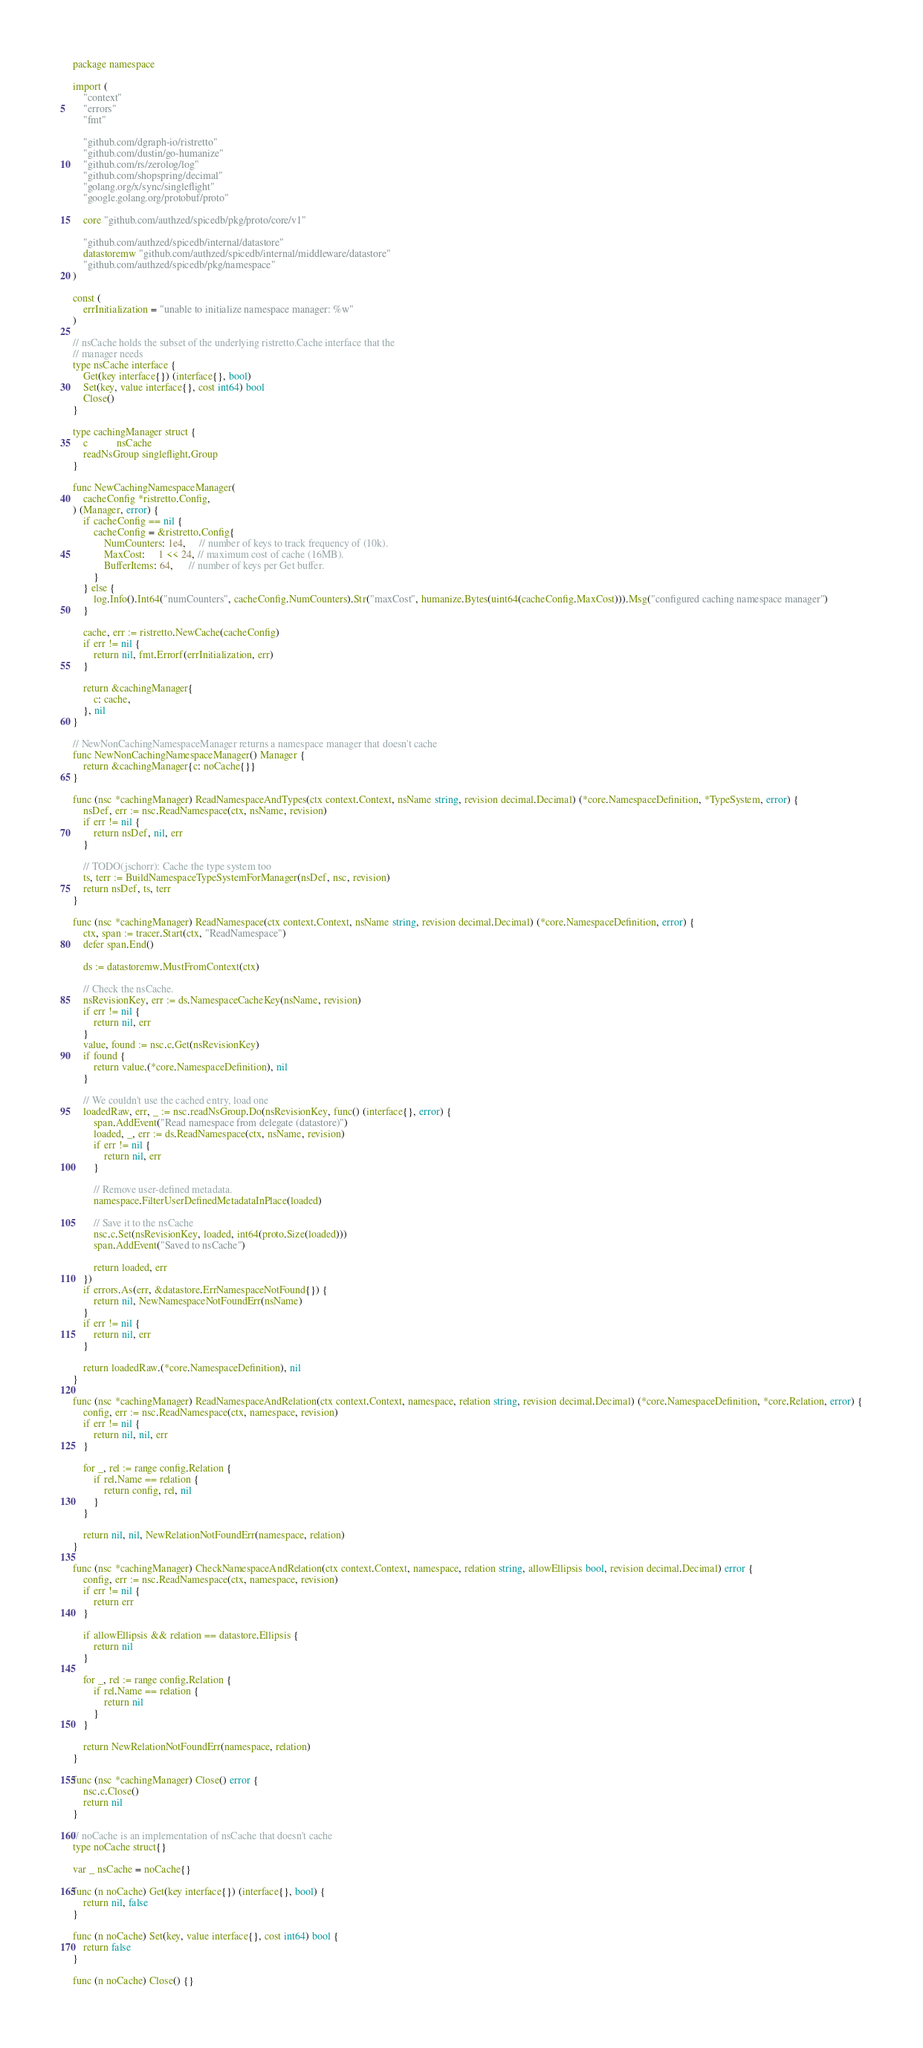Convert code to text. <code><loc_0><loc_0><loc_500><loc_500><_Go_>package namespace

import (
	"context"
	"errors"
	"fmt"

	"github.com/dgraph-io/ristretto"
	"github.com/dustin/go-humanize"
	"github.com/rs/zerolog/log"
	"github.com/shopspring/decimal"
	"golang.org/x/sync/singleflight"
	"google.golang.org/protobuf/proto"

	core "github.com/authzed/spicedb/pkg/proto/core/v1"

	"github.com/authzed/spicedb/internal/datastore"
	datastoremw "github.com/authzed/spicedb/internal/middleware/datastore"
	"github.com/authzed/spicedb/pkg/namespace"
)

const (
	errInitialization = "unable to initialize namespace manager: %w"
)

// nsCache holds the subset of the underlying ristretto.Cache interface that the
// manager needs
type nsCache interface {
	Get(key interface{}) (interface{}, bool)
	Set(key, value interface{}, cost int64) bool
	Close()
}

type cachingManager struct {
	c           nsCache
	readNsGroup singleflight.Group
}

func NewCachingNamespaceManager(
	cacheConfig *ristretto.Config,
) (Manager, error) {
	if cacheConfig == nil {
		cacheConfig = &ristretto.Config{
			NumCounters: 1e4,     // number of keys to track frequency of (10k).
			MaxCost:     1 << 24, // maximum cost of cache (16MB).
			BufferItems: 64,      // number of keys per Get buffer.
		}
	} else {
		log.Info().Int64("numCounters", cacheConfig.NumCounters).Str("maxCost", humanize.Bytes(uint64(cacheConfig.MaxCost))).Msg("configured caching namespace manager")
	}

	cache, err := ristretto.NewCache(cacheConfig)
	if err != nil {
		return nil, fmt.Errorf(errInitialization, err)
	}

	return &cachingManager{
		c: cache,
	}, nil
}

// NewNonCachingNamespaceManager returns a namespace manager that doesn't cache
func NewNonCachingNamespaceManager() Manager {
	return &cachingManager{c: noCache{}}
}

func (nsc *cachingManager) ReadNamespaceAndTypes(ctx context.Context, nsName string, revision decimal.Decimal) (*core.NamespaceDefinition, *TypeSystem, error) {
	nsDef, err := nsc.ReadNamespace(ctx, nsName, revision)
	if err != nil {
		return nsDef, nil, err
	}

	// TODO(jschorr): Cache the type system too
	ts, terr := BuildNamespaceTypeSystemForManager(nsDef, nsc, revision)
	return nsDef, ts, terr
}

func (nsc *cachingManager) ReadNamespace(ctx context.Context, nsName string, revision decimal.Decimal) (*core.NamespaceDefinition, error) {
	ctx, span := tracer.Start(ctx, "ReadNamespace")
	defer span.End()

	ds := datastoremw.MustFromContext(ctx)

	// Check the nsCache.
	nsRevisionKey, err := ds.NamespaceCacheKey(nsName, revision)
	if err != nil {
		return nil, err
	}
	value, found := nsc.c.Get(nsRevisionKey)
	if found {
		return value.(*core.NamespaceDefinition), nil
	}

	// We couldn't use the cached entry, load one
	loadedRaw, err, _ := nsc.readNsGroup.Do(nsRevisionKey, func() (interface{}, error) {
		span.AddEvent("Read namespace from delegate (datastore)")
		loaded, _, err := ds.ReadNamespace(ctx, nsName, revision)
		if err != nil {
			return nil, err
		}

		// Remove user-defined metadata.
		namespace.FilterUserDefinedMetadataInPlace(loaded)

		// Save it to the nsCache
		nsc.c.Set(nsRevisionKey, loaded, int64(proto.Size(loaded)))
		span.AddEvent("Saved to nsCache")

		return loaded, err
	})
	if errors.As(err, &datastore.ErrNamespaceNotFound{}) {
		return nil, NewNamespaceNotFoundErr(nsName)
	}
	if err != nil {
		return nil, err
	}

	return loadedRaw.(*core.NamespaceDefinition), nil
}

func (nsc *cachingManager) ReadNamespaceAndRelation(ctx context.Context, namespace, relation string, revision decimal.Decimal) (*core.NamespaceDefinition, *core.Relation, error) {
	config, err := nsc.ReadNamespace(ctx, namespace, revision)
	if err != nil {
		return nil, nil, err
	}

	for _, rel := range config.Relation {
		if rel.Name == relation {
			return config, rel, nil
		}
	}

	return nil, nil, NewRelationNotFoundErr(namespace, relation)
}

func (nsc *cachingManager) CheckNamespaceAndRelation(ctx context.Context, namespace, relation string, allowEllipsis bool, revision decimal.Decimal) error {
	config, err := nsc.ReadNamespace(ctx, namespace, revision)
	if err != nil {
		return err
	}

	if allowEllipsis && relation == datastore.Ellipsis {
		return nil
	}

	for _, rel := range config.Relation {
		if rel.Name == relation {
			return nil
		}
	}

	return NewRelationNotFoundErr(namespace, relation)
}

func (nsc *cachingManager) Close() error {
	nsc.c.Close()
	return nil
}

// noCache is an implementation of nsCache that doesn't cache
type noCache struct{}

var _ nsCache = noCache{}

func (n noCache) Get(key interface{}) (interface{}, bool) {
	return nil, false
}

func (n noCache) Set(key, value interface{}, cost int64) bool {
	return false
}

func (n noCache) Close() {}
</code> 